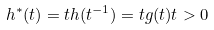<formula> <loc_0><loc_0><loc_500><loc_500>h ^ { * } ( t ) = t h ( t ^ { - 1 } ) = t g ( t ) t > 0</formula> 